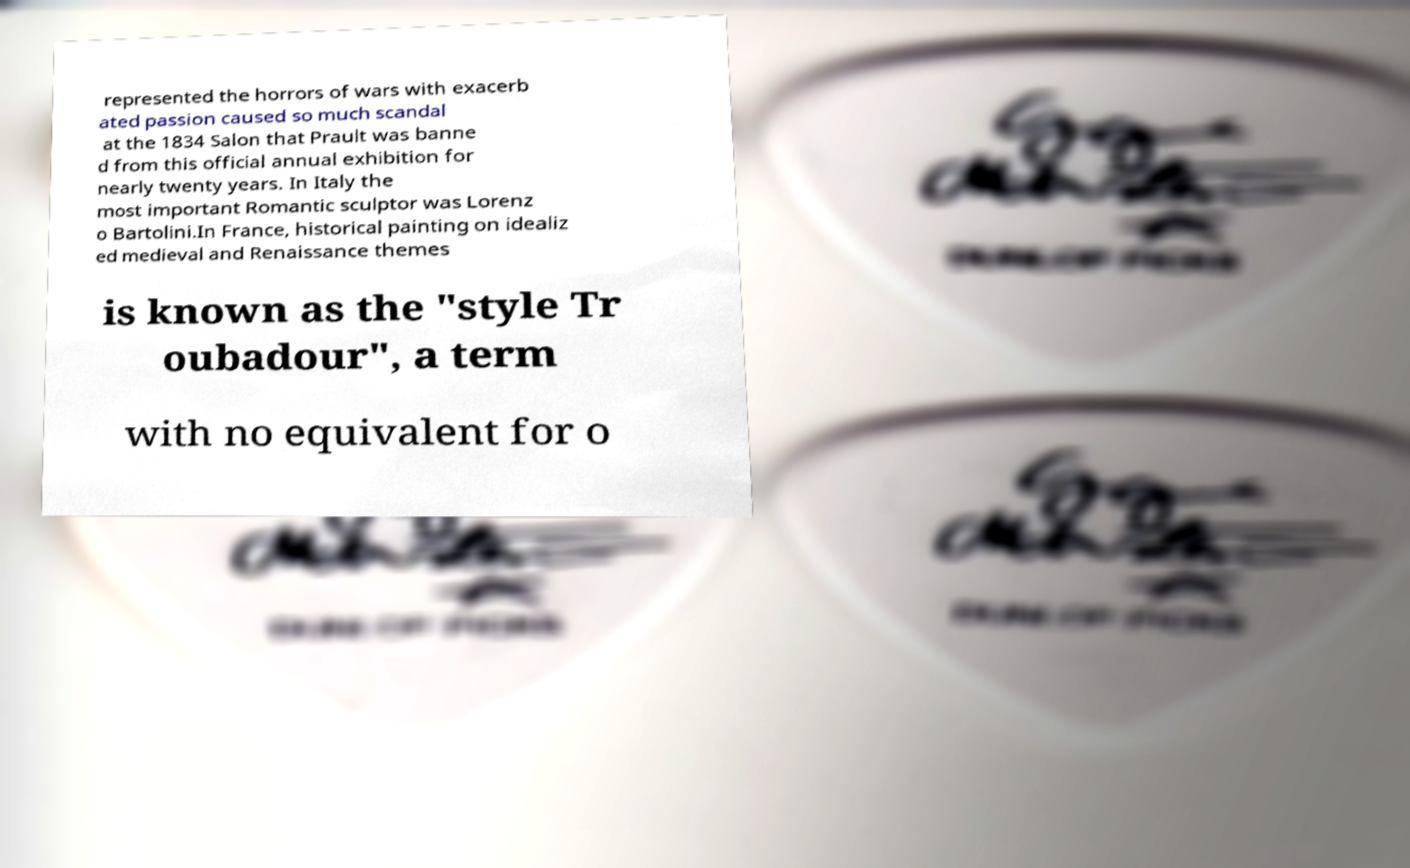Can you read and provide the text displayed in the image?This photo seems to have some interesting text. Can you extract and type it out for me? represented the horrors of wars with exacerb ated passion caused so much scandal at the 1834 Salon that Prault was banne d from this official annual exhibition for nearly twenty years. In Italy the most important Romantic sculptor was Lorenz o Bartolini.In France, historical painting on idealiz ed medieval and Renaissance themes is known as the "style Tr oubadour", a term with no equivalent for o 